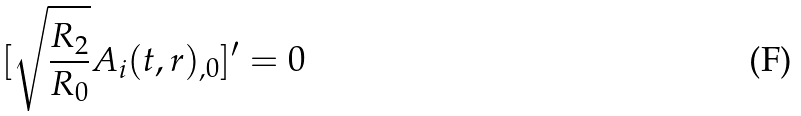<formula> <loc_0><loc_0><loc_500><loc_500>[ \sqrt { \frac { R _ { 2 } } { R _ { 0 } } } A _ { i } ( t , r ) _ { , 0 } ] ^ { \prime } = 0</formula> 